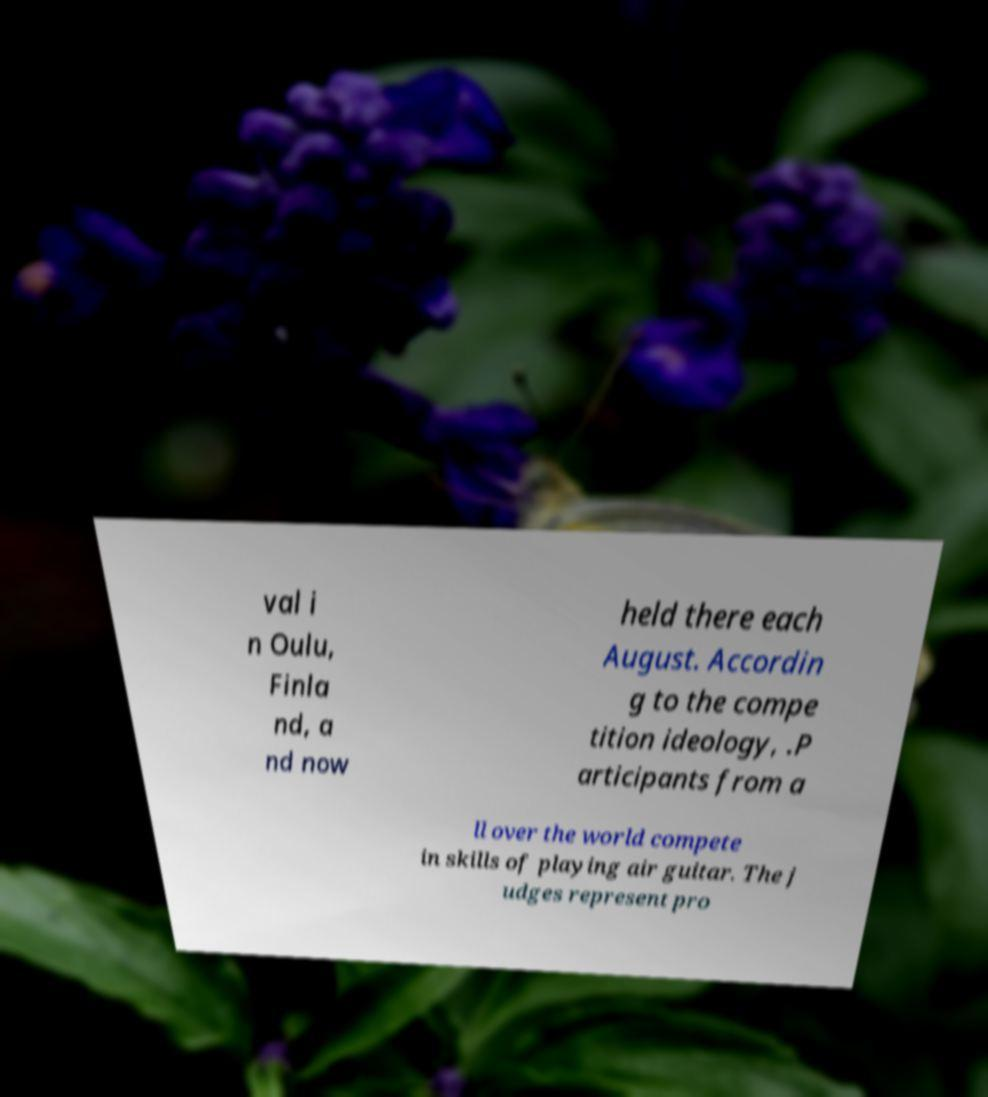There's text embedded in this image that I need extracted. Can you transcribe it verbatim? val i n Oulu, Finla nd, a nd now held there each August. Accordin g to the compe tition ideology, .P articipants from a ll over the world compete in skills of playing air guitar. The j udges represent pro 